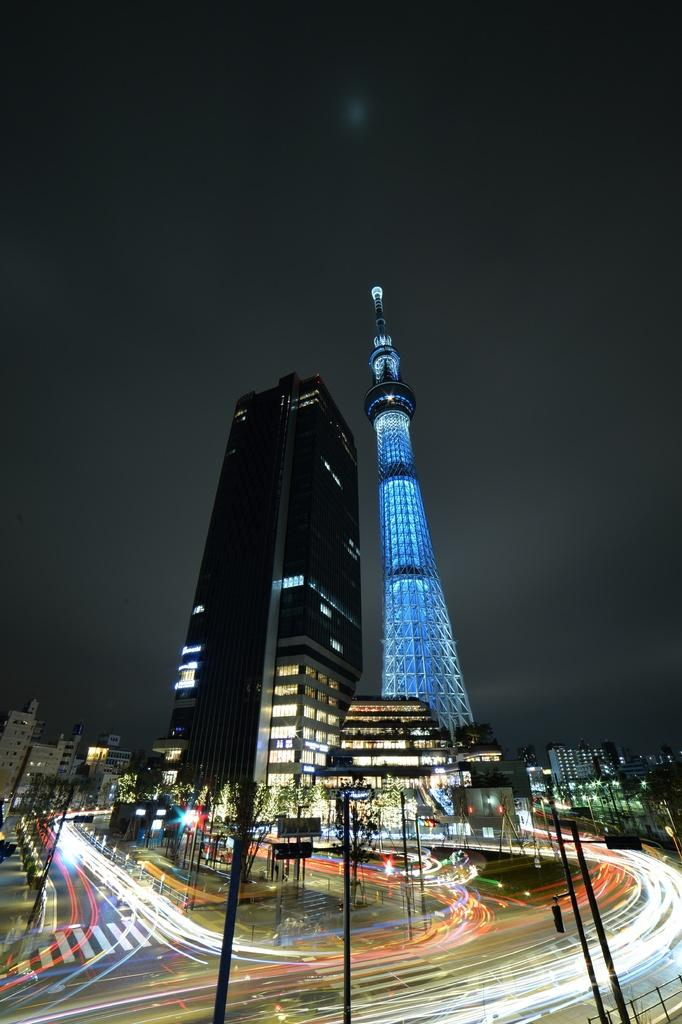What type of structures can be seen in the image? There are buildings and a tower in the image. What other objects are present in the image? There are poles, lights, and boards in the image. How would you describe the sky in the image? The sky is dark in the image. Can you describe the unspecified objects in the image? Unfortunately, the provided facts do not specify the nature of these objects. How many mittens can be seen on the tower in the image? There are no mittens present in the image. What type of frogs are hopping on the boards in the image? There are no frogs present in the image. 